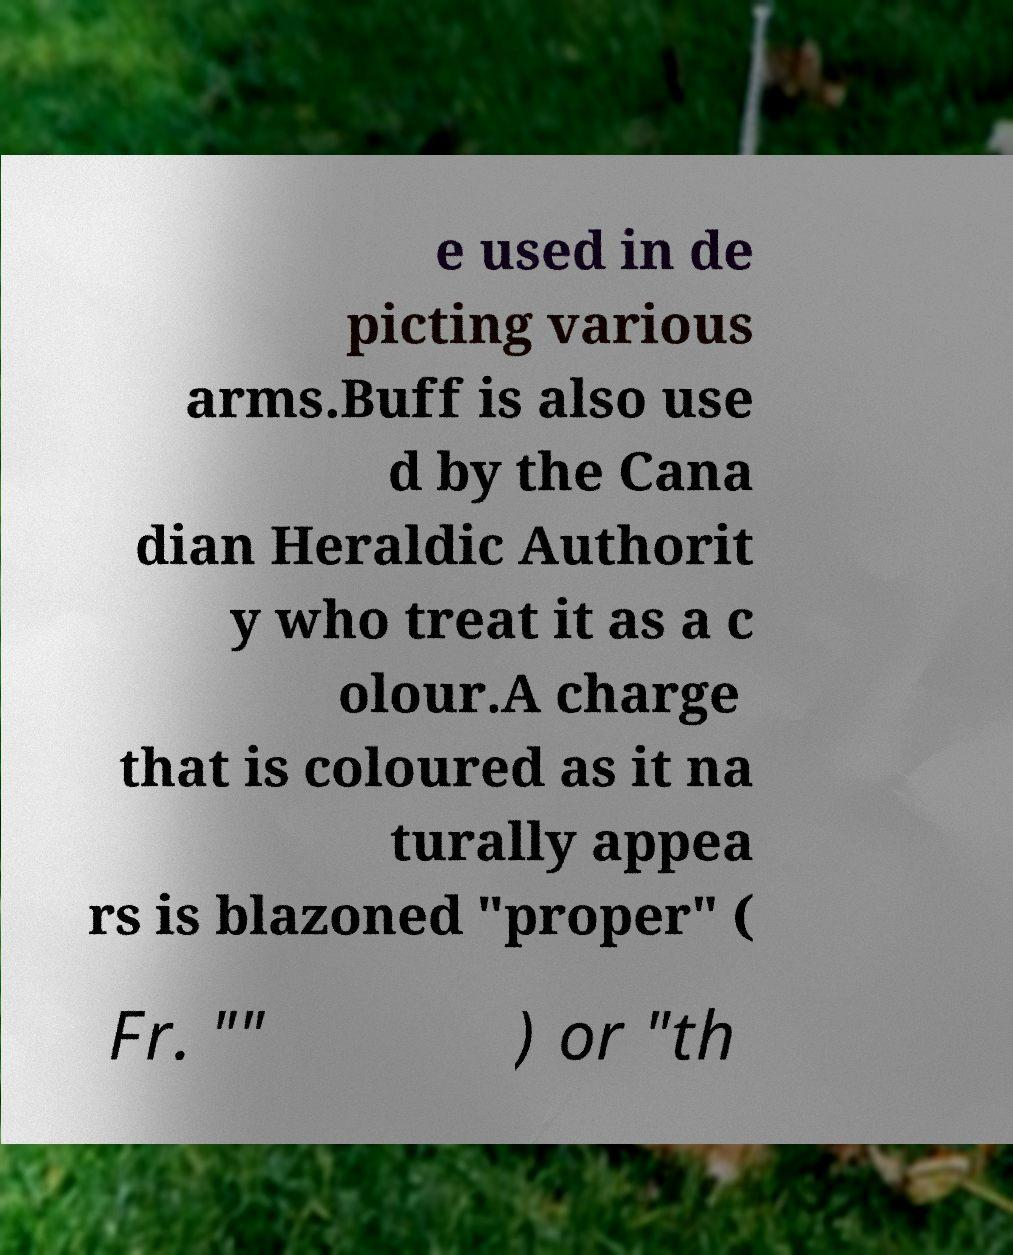Can you accurately transcribe the text from the provided image for me? e used in de picting various arms.Buff is also use d by the Cana dian Heraldic Authorit y who treat it as a c olour.A charge that is coloured as it na turally appea rs is blazoned "proper" ( Fr. "" ) or "th 